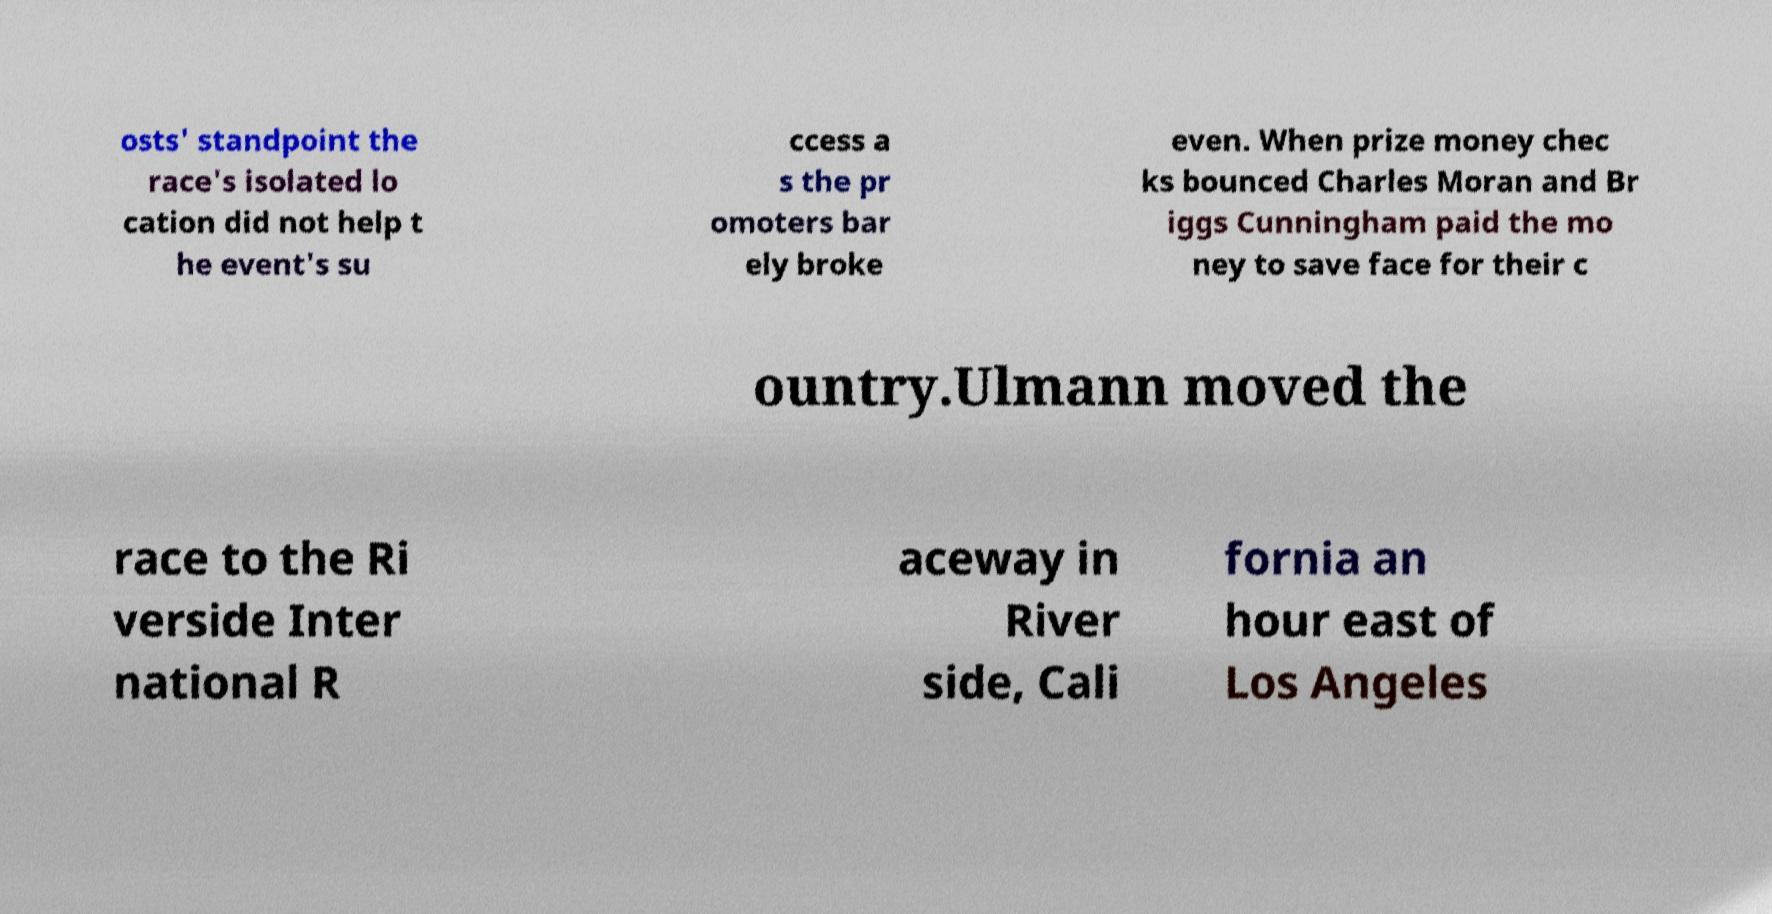For documentation purposes, I need the text within this image transcribed. Could you provide that? osts' standpoint the race's isolated lo cation did not help t he event's su ccess a s the pr omoters bar ely broke even. When prize money chec ks bounced Charles Moran and Br iggs Cunningham paid the mo ney to save face for their c ountry.Ulmann moved the race to the Ri verside Inter national R aceway in River side, Cali fornia an hour east of Los Angeles 